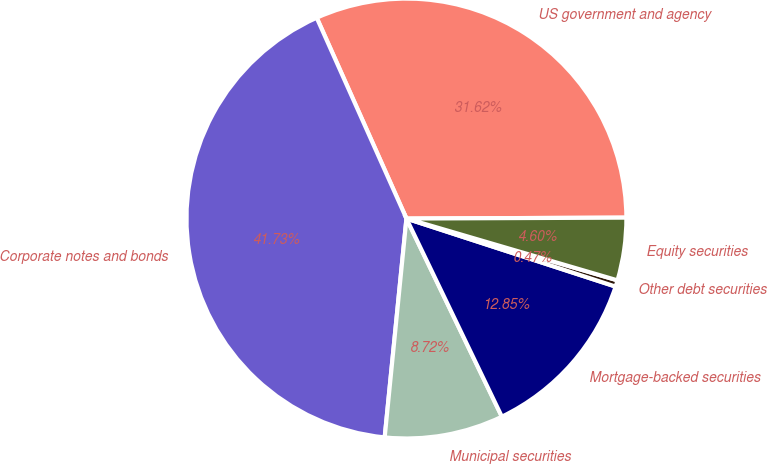Convert chart to OTSL. <chart><loc_0><loc_0><loc_500><loc_500><pie_chart><fcel>US government and agency<fcel>Corporate notes and bonds<fcel>Municipal securities<fcel>Mortgage-backed securities<fcel>Other debt securities<fcel>Equity securities<nl><fcel>31.62%<fcel>41.73%<fcel>8.72%<fcel>12.85%<fcel>0.47%<fcel>4.6%<nl></chart> 